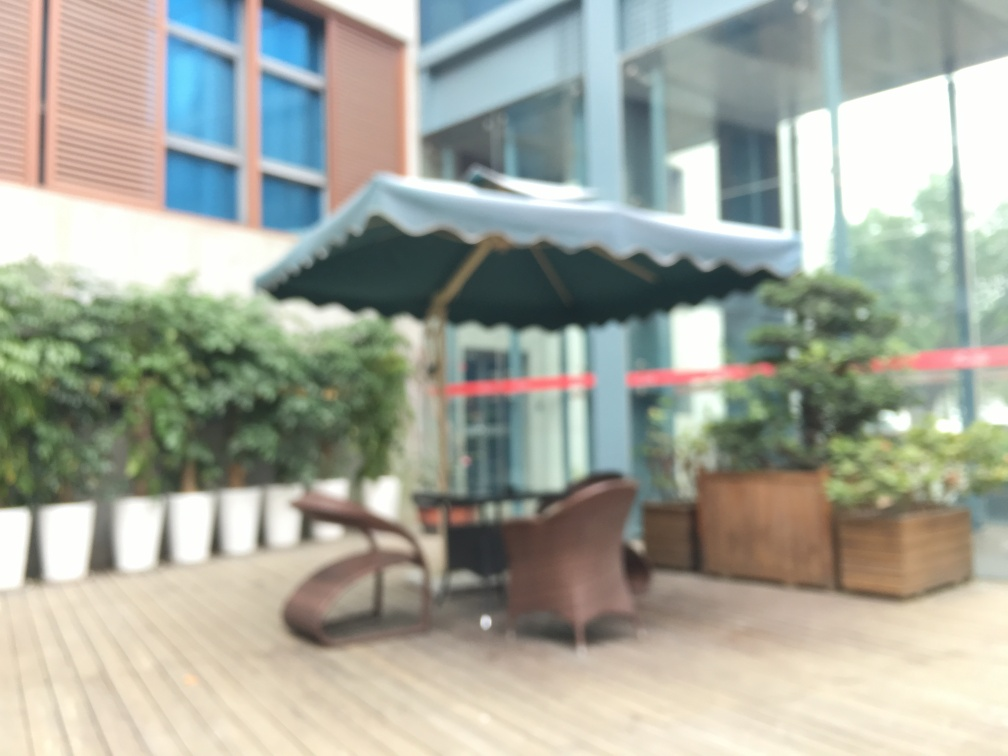Are there any people in the image? It's difficult to determine with certainty due to the blurring, but there appear to be no distinct shapes or shadows that would indicate the presence of people in this part of the image. 